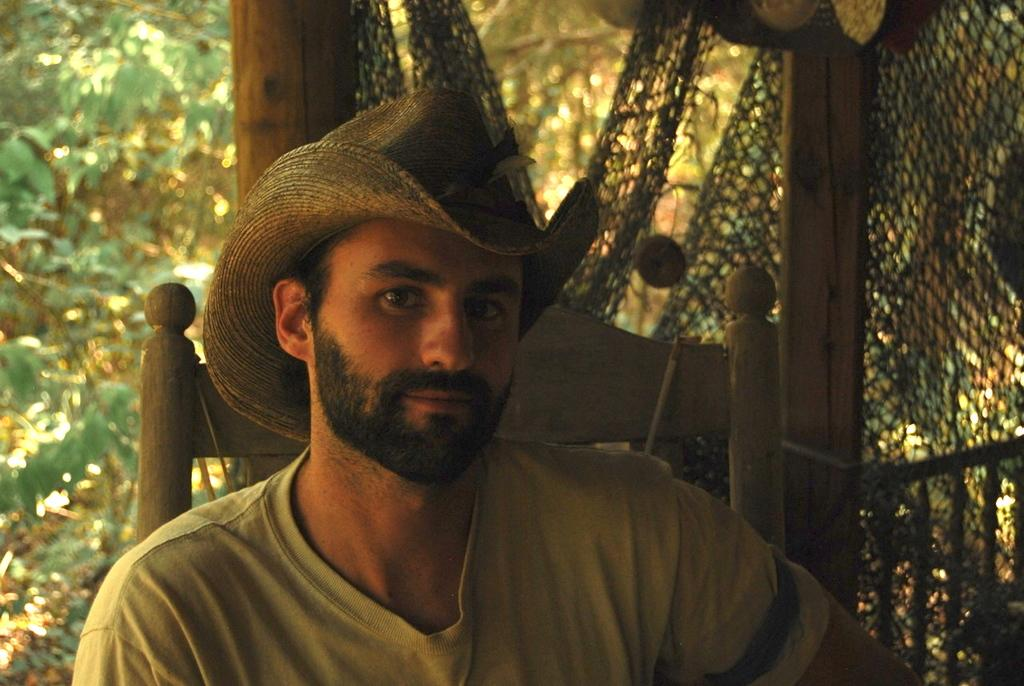What is the man in the image doing? The man is sitting in the image. What is located behind the man? There is fencing behind the man. What can be seen beyond the fencing? Trees are visible behind the fencing. Where is the bomb hidden in the image? There is no bomb present in the image. What type of stone can be seen in the image? There is no stone visible in the image. 